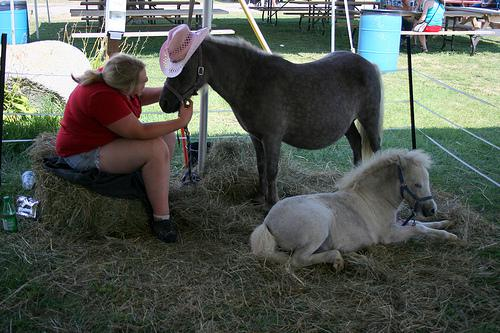Question: how many horses?
Choices:
A. Three.
B. Four.
C. Two.
D. Five.
Answer with the letter. Answer: C Question: who is in the pen with them?
Choices:
A. Man.
B. Lady.
C. Boy.
D. Girl.
Answer with the letter. Answer: B Question: what is she doing?
Choices:
A. Feeding the horses.
B. Riding the horses.
C. Caring for the horses.
D. Brushing the horses.
Answer with the letter. Answer: C Question: where are the horses?
Choices:
A. In the stable.
B. In the pen.
C. In the field.
D. In the trailer.
Answer with the letter. Answer: B 